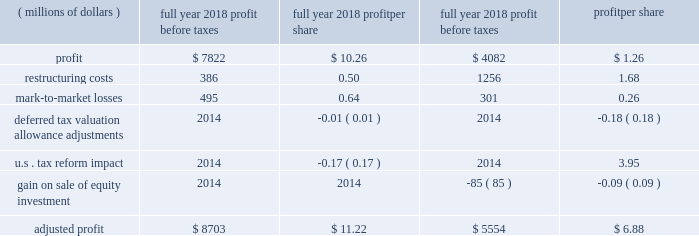2018 a0form 10-k18 item 7 .
Management 2019s discussion and analysis of financial condition and results of operations .
This management 2019s discussion and analysis of financial condition and results of operations should be read in conjunction with our discussion of cautionary statements and significant risks to the company 2019s business under item 1a .
Risk factors of the 2018 form a010-k .
Overview our sales and revenues for 2018 were $ 54.722 billion , a 20 a0percent increase from 2017 sales and revenues of $ 45.462 a0billion .
The increase was primarily due to higher sales volume , mostly due to improved demand across all regions and across the three primary segments .
Profit per share for 2018 was $ 10.26 , compared to profit per share of $ 1.26 in 2017 .
Profit was $ 6.147 billion in 2018 , compared with $ 754 million in 2017 .
The increase was primarily due to lower tax expense , higher sales volume , decreased restructuring costs and improved price realization .
The increase was partially offset by higher manufacturing costs and selling , general and administrative ( sg&a ) and research and development ( r&d ) expenses and lower profit from the financial products segment .
Fourth-quarter 2018 sales and revenues were $ 14.342 billion , up $ 1.446 billion , or 11 percent , from $ 12.896 billion in the fourth quarter of 2017 .
Fourth-quarter 2018 profit was $ 1.78 per share , compared with a loss of $ 2.18 per share in the fourth quarter of 2017 .
Fourth-quarter 2018 profit was $ 1.048 billion , compared with a loss of $ 1.299 billion in 2017 .
Highlights for 2018 include : zz sales and revenues in 2018 were $ 54.722 billion , up 20 a0percent from 2017 .
Sales improved in all regions and across the three primary segments .
Zz operating profit as a percent of sales and revenues was 15.2 a0percent in 2018 , compared with 9.8 percent in 2017 .
Adjusted operating profit margin was 15.9 percent in 2018 , compared with 12.5 percent in 2017 .
Zz profit was $ 10.26 per share for 2018 , and excluding the items in the table below , adjusted profit per share was $ 11.22 .
For 2017 profit was $ 1.26 per share , and excluding the items in the table below , adjusted profit per share was $ 6.88 .
Zz in order for our results to be more meaningful to our readers , we have separately quantified the impact of several significant items: .
Zz machinery , energy & transportation ( me&t ) operating cash flow for 2018 was about $ 6.3 billion , more than sufficient to cover capital expenditures and dividends .
Me&t operating cash flow for 2017 was about $ 5.5 billion .
Restructuring costs in recent years , we have incurred substantial restructuring costs to achieve a flexible and competitive cost structure .
During 2018 , we incurred $ 386 million of restructuring costs related to restructuring actions across the company .
During 2017 , we incurred $ 1.256 billion of restructuring costs with about half related to the closure of the facility in gosselies , belgium , and the remainder related to other restructuring actions across the company .
Although we expect restructuring to continue as part of ongoing business activities , restructuring costs should be lower in 2019 than 2018 .
Notes : zz glossary of terms included on pages 33-34 ; first occurrence of terms shown in bold italics .
Zz information on non-gaap financial measures is included on pages 42-43. .
What would profit per share be in 2019 with the same growth rate as 2018?\\n\\n? 
Computations: ((10.26 / 1.26) * 10.26)
Answer: 83.54571. 2018 a0form 10-k18 item 7 .
Management 2019s discussion and analysis of financial condition and results of operations .
This management 2019s discussion and analysis of financial condition and results of operations should be read in conjunction with our discussion of cautionary statements and significant risks to the company 2019s business under item 1a .
Risk factors of the 2018 form a010-k .
Overview our sales and revenues for 2018 were $ 54.722 billion , a 20 a0percent increase from 2017 sales and revenues of $ 45.462 a0billion .
The increase was primarily due to higher sales volume , mostly due to improved demand across all regions and across the three primary segments .
Profit per share for 2018 was $ 10.26 , compared to profit per share of $ 1.26 in 2017 .
Profit was $ 6.147 billion in 2018 , compared with $ 754 million in 2017 .
The increase was primarily due to lower tax expense , higher sales volume , decreased restructuring costs and improved price realization .
The increase was partially offset by higher manufacturing costs and selling , general and administrative ( sg&a ) and research and development ( r&d ) expenses and lower profit from the financial products segment .
Fourth-quarter 2018 sales and revenues were $ 14.342 billion , up $ 1.446 billion , or 11 percent , from $ 12.896 billion in the fourth quarter of 2017 .
Fourth-quarter 2018 profit was $ 1.78 per share , compared with a loss of $ 2.18 per share in the fourth quarter of 2017 .
Fourth-quarter 2018 profit was $ 1.048 billion , compared with a loss of $ 1.299 billion in 2017 .
Highlights for 2018 include : zz sales and revenues in 2018 were $ 54.722 billion , up 20 a0percent from 2017 .
Sales improved in all regions and across the three primary segments .
Zz operating profit as a percent of sales and revenues was 15.2 a0percent in 2018 , compared with 9.8 percent in 2017 .
Adjusted operating profit margin was 15.9 percent in 2018 , compared with 12.5 percent in 2017 .
Zz profit was $ 10.26 per share for 2018 , and excluding the items in the table below , adjusted profit per share was $ 11.22 .
For 2017 profit was $ 1.26 per share , and excluding the items in the table below , adjusted profit per share was $ 6.88 .
Zz in order for our results to be more meaningful to our readers , we have separately quantified the impact of several significant items: .
Zz machinery , energy & transportation ( me&t ) operating cash flow for 2018 was about $ 6.3 billion , more than sufficient to cover capital expenditures and dividends .
Me&t operating cash flow for 2017 was about $ 5.5 billion .
Restructuring costs in recent years , we have incurred substantial restructuring costs to achieve a flexible and competitive cost structure .
During 2018 , we incurred $ 386 million of restructuring costs related to restructuring actions across the company .
During 2017 , we incurred $ 1.256 billion of restructuring costs with about half related to the closure of the facility in gosselies , belgium , and the remainder related to other restructuring actions across the company .
Although we expect restructuring to continue as part of ongoing business activities , restructuring costs should be lower in 2019 than 2018 .
Notes : zz glossary of terms included on pages 33-34 ; first occurrence of terms shown in bold italics .
Zz information on non-gaap financial measures is included on pages 42-43. .
What is the profit margin in 2018? 
Computations: (6.147 / 54.722)
Answer: 0.11233. 